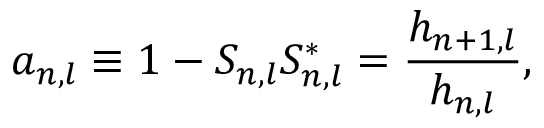Convert formula to latex. <formula><loc_0><loc_0><loc_500><loc_500>a _ { n , l } \equiv 1 - S _ { n , l } S _ { n , l } ^ { * } = \frac { h _ { n + 1 , l } } { h _ { n , l } } ,</formula> 